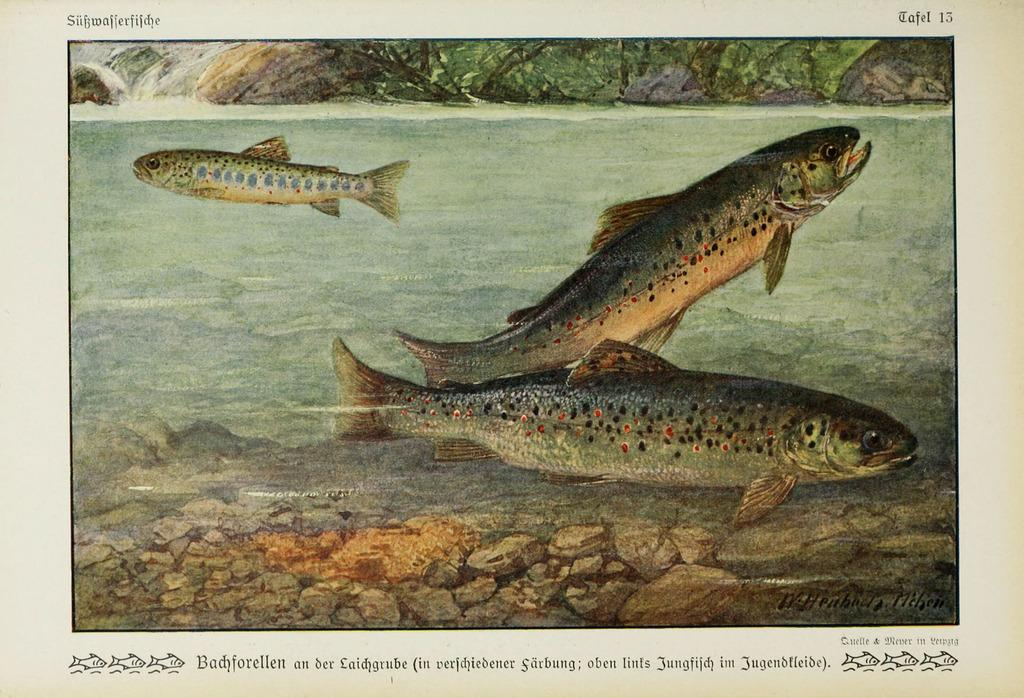What type of artwork is depicted in the image? The image is a painting. What is the main feature of the painting? There is a pond in the center of the painting. What can be found in the pond? There are fishes, water, and stones in the pond. Where is the rock located in the painting? There is a rock at the top of the painting. What is written at the bottom of the painting? There is text at the bottom of the painting. What is the taste of the war depicted in the painting? There is no war depicted in the painting; it features a pond with fishes, water, and stones. What act is being performed by the fish in the painting? The fish in the painting are not performing any act; they are simply swimming in the pond. 